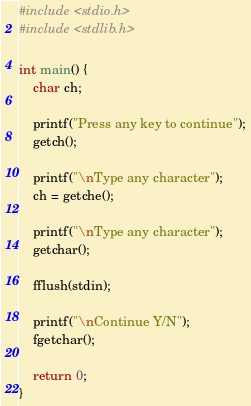Convert code to text. <code><loc_0><loc_0><loc_500><loc_500><_C_>#include <stdio.h>
#include <stdlib.h>

int main() {
    char ch;

    printf("Press any key to continue");
    getch();

    printf("\nType any character");
    ch = getche();

    printf("\nType any character");
    getchar();

    fflush(stdin);

    printf("\nContinue Y/N");
    fgetchar();

    return 0;
}
</code> 